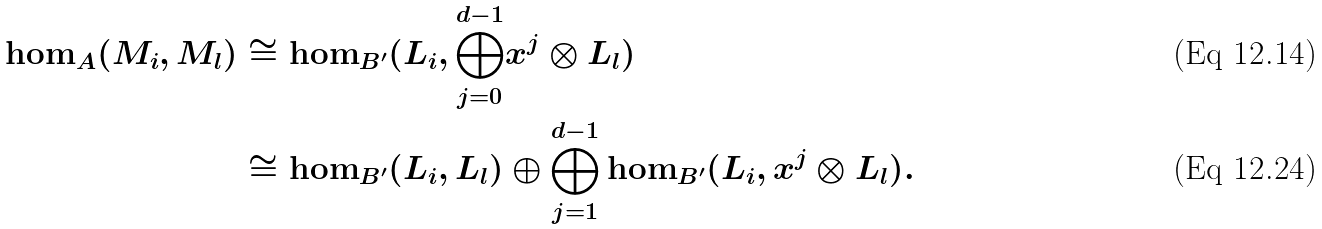<formula> <loc_0><loc_0><loc_500><loc_500>\hom _ { A } ( M _ { i } , M _ { l } ) & \cong \hom _ { B ^ { \prime } } ( L _ { i } , \overset { d - 1 } { \underset { j = 0 } { \bigoplus } } x ^ { j } \otimes L _ { l } ) \\ & \cong \hom _ { B ^ { \prime } } ( L _ { i } , L _ { l } ) \oplus \overset { d - 1 } { \underset { j = 1 } { \bigoplus } } \hom _ { B ^ { \prime } } ( L _ { i } , x ^ { j } \otimes L _ { l } ) .</formula> 